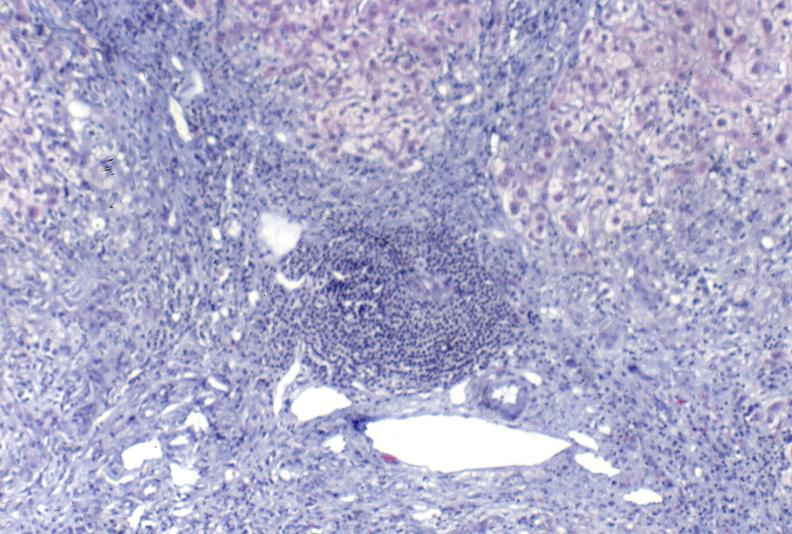what does this image show?
Answer the question using a single word or phrase. Primary biliary cirrhosis 